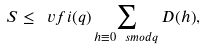Convert formula to latex. <formula><loc_0><loc_0><loc_500><loc_500>S \leq \ v f i ( q ) \sum _ { h \equiv 0 \ s m o d { q } } D ( h ) ,</formula> 